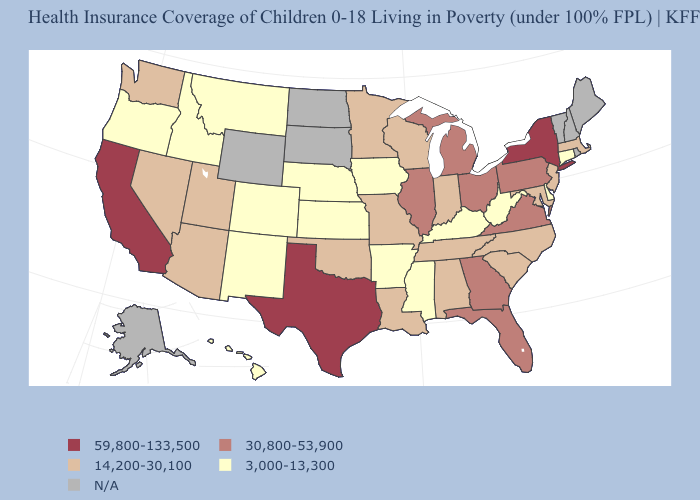What is the value of Kentucky?
Short answer required. 3,000-13,300. What is the value of Utah?
Answer briefly. 14,200-30,100. Which states have the lowest value in the MidWest?
Short answer required. Iowa, Kansas, Nebraska. Name the states that have a value in the range 59,800-133,500?
Concise answer only. California, New York, Texas. What is the value of Louisiana?
Quick response, please. 14,200-30,100. Does Texas have the highest value in the South?
Concise answer only. Yes. What is the value of Kentucky?
Be succinct. 3,000-13,300. What is the value of Virginia?
Concise answer only. 30,800-53,900. Name the states that have a value in the range 59,800-133,500?
Concise answer only. California, New York, Texas. Among the states that border Delaware , which have the lowest value?
Keep it brief. Maryland, New Jersey. Name the states that have a value in the range 14,200-30,100?
Short answer required. Alabama, Arizona, Indiana, Louisiana, Maryland, Massachusetts, Minnesota, Missouri, Nevada, New Jersey, North Carolina, Oklahoma, South Carolina, Tennessee, Utah, Washington, Wisconsin. What is the lowest value in the USA?
Keep it brief. 3,000-13,300. 